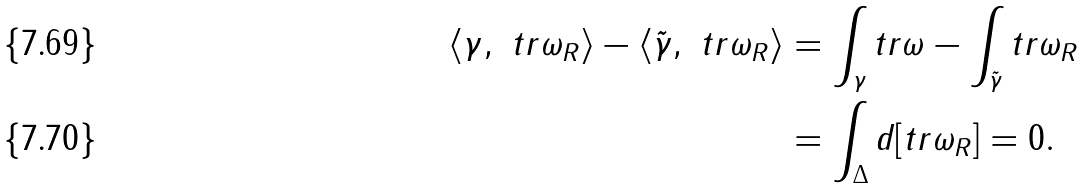<formula> <loc_0><loc_0><loc_500><loc_500>\langle \gamma , \ t r \omega _ { R } \rangle - \langle \tilde { \gamma } , \ t r \omega _ { R } \rangle & = \int _ { \gamma } t r \omega - \int _ { \tilde { \gamma } } t r \omega _ { R } \\ & = \int _ { \Delta } d [ t r \omega _ { R } ] = 0 .</formula> 